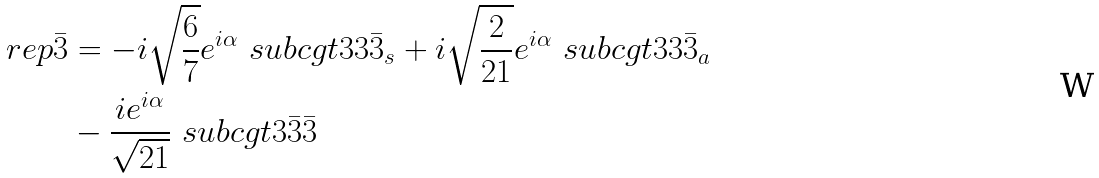<formula> <loc_0><loc_0><loc_500><loc_500>\ r e p { \bar { 3 } } & = - i \sqrt { \frac { 6 } { 7 } } e ^ { i \alpha } \ s u b c g t { 3 } { 3 } { \bar { 3 } _ { s } } + i \sqrt { \frac { 2 } { 2 1 } } e ^ { i \alpha } \ s u b c g t { 3 } { 3 } { \bar { 3 } _ { a } } \\ & - \frac { i e ^ { i \alpha } } { \sqrt { 2 1 } } \ s u b c g t { 3 } { \bar { 3 } } { \bar { 3 } }</formula> 